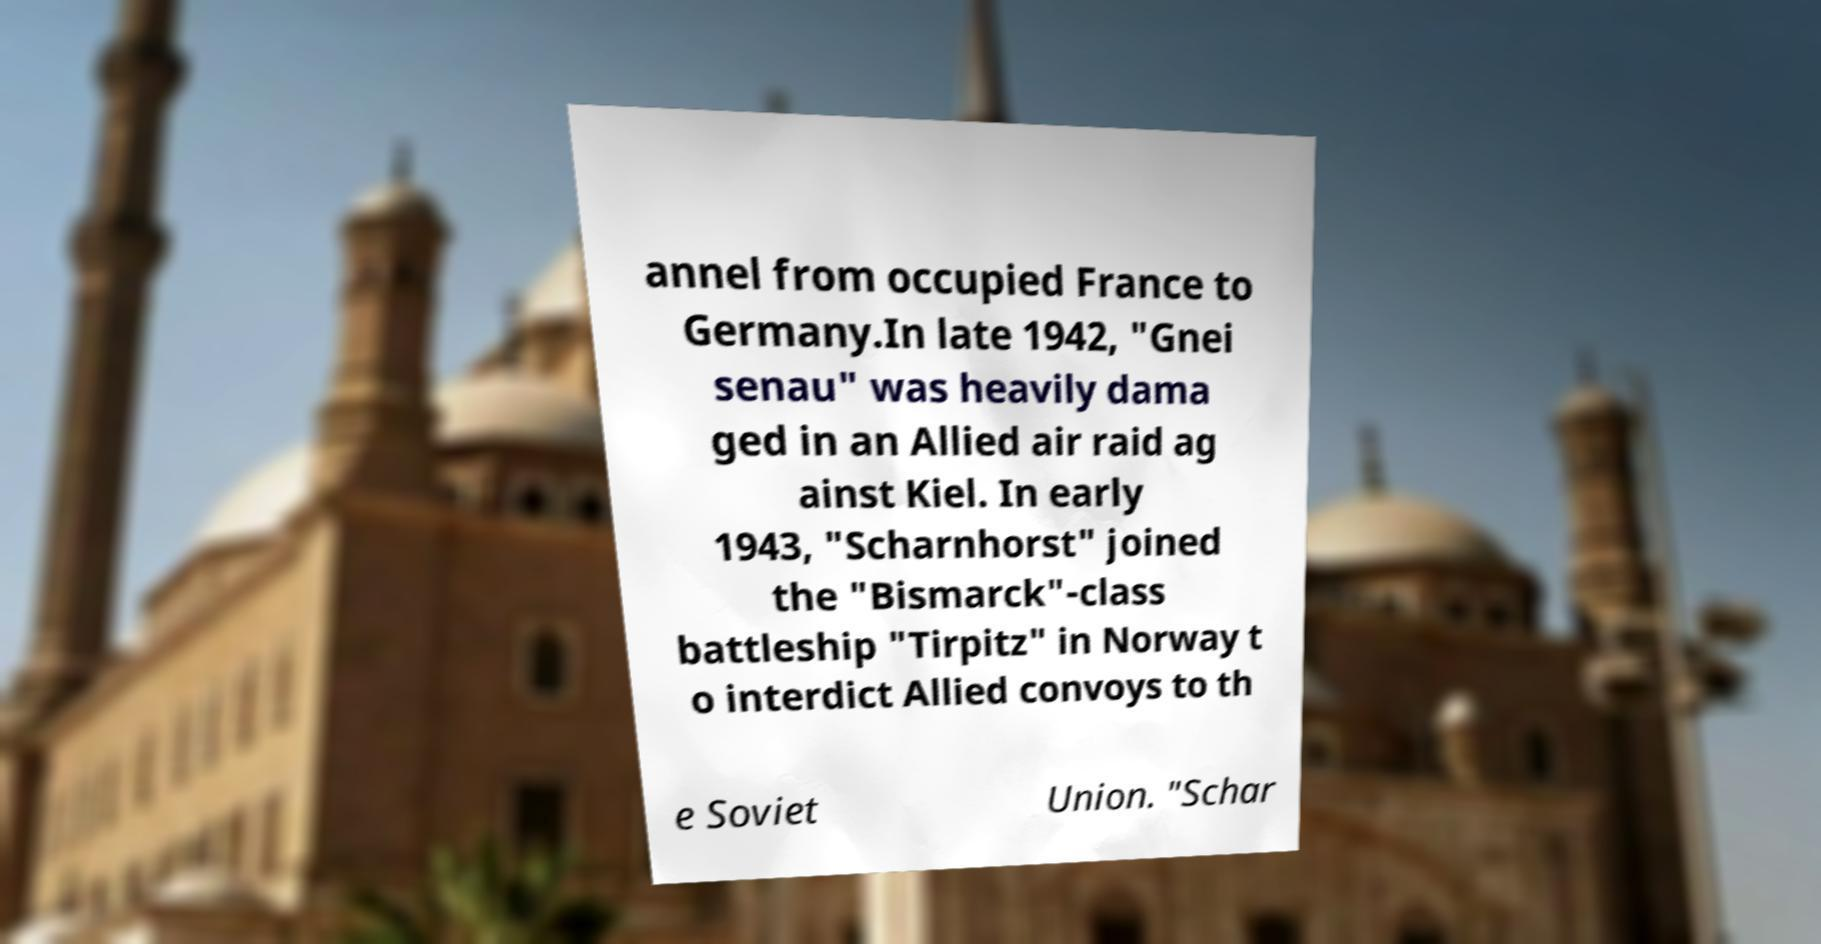I need the written content from this picture converted into text. Can you do that? annel from occupied France to Germany.In late 1942, "Gnei senau" was heavily dama ged in an Allied air raid ag ainst Kiel. In early 1943, "Scharnhorst" joined the "Bismarck"-class battleship "Tirpitz" in Norway t o interdict Allied convoys to th e Soviet Union. "Schar 